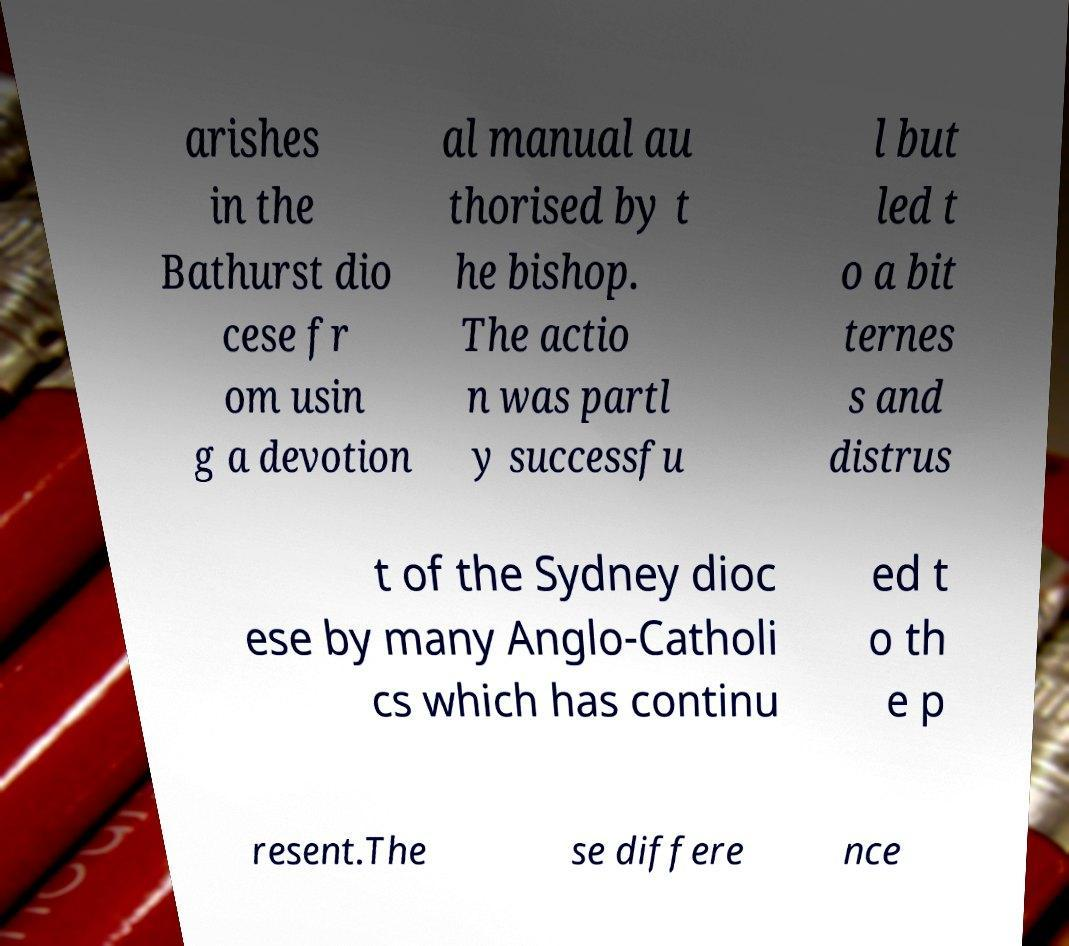Could you extract and type out the text from this image? arishes in the Bathurst dio cese fr om usin g a devotion al manual au thorised by t he bishop. The actio n was partl y successfu l but led t o a bit ternes s and distrus t of the Sydney dioc ese by many Anglo-Catholi cs which has continu ed t o th e p resent.The se differe nce 